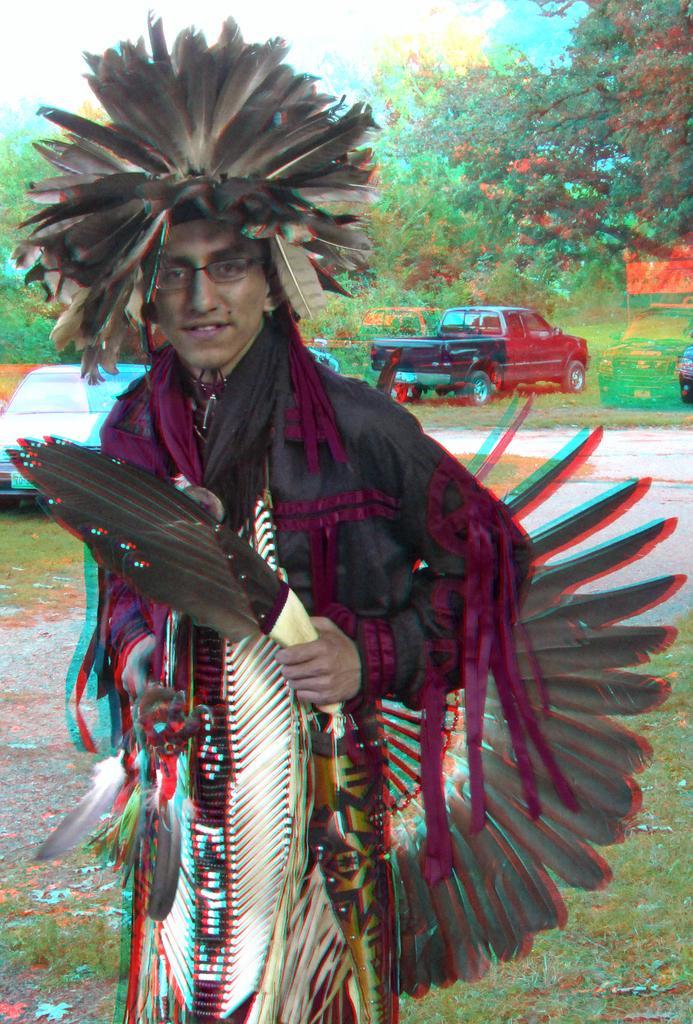In one or two sentences, can you explain what this image depicts? In this image a person is wearing a costume. He is having some feather on his head. He is standing on the grassland having a car on it. Few vehicles are on the grassland. Background there are few trees. Top of image there is sky. 